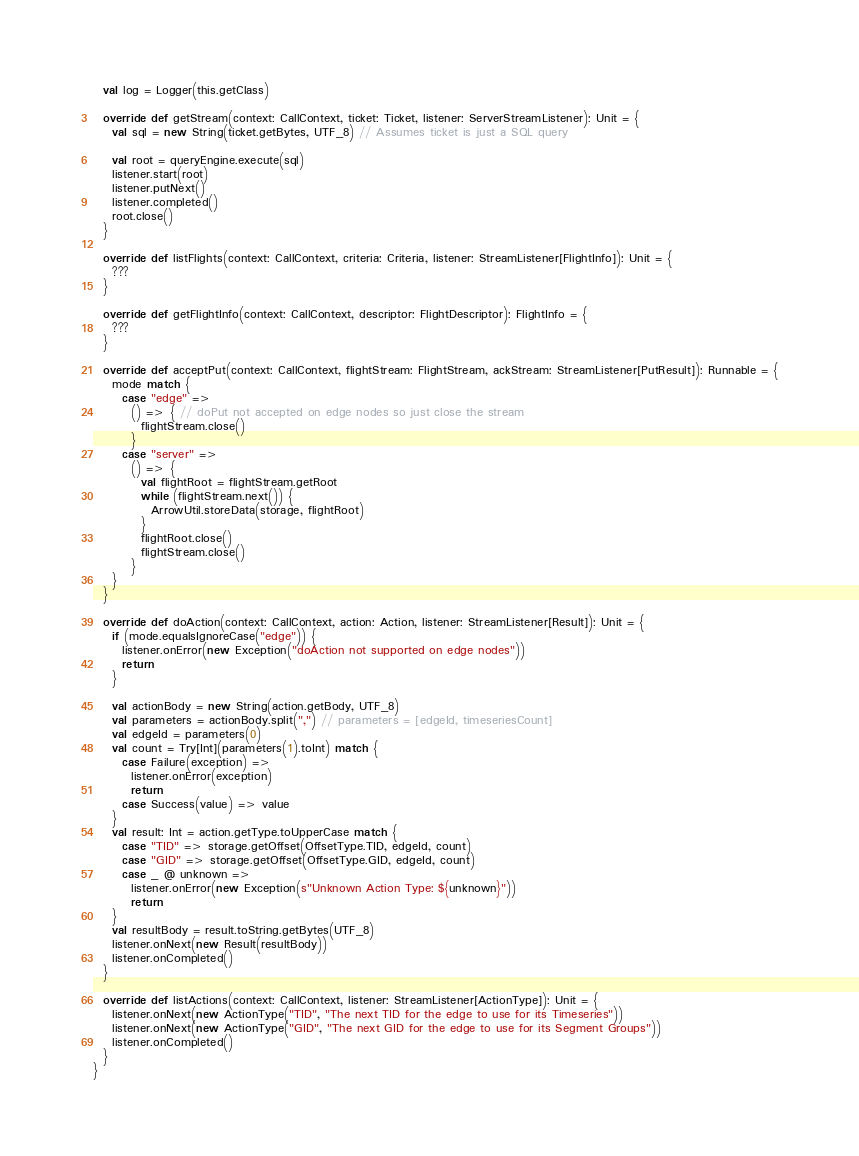Convert code to text. <code><loc_0><loc_0><loc_500><loc_500><_Scala_>
  val log = Logger(this.getClass)

  override def getStream(context: CallContext, ticket: Ticket, listener: ServerStreamListener): Unit = {
    val sql = new String(ticket.getBytes, UTF_8) // Assumes ticket is just a SQL query

    val root = queryEngine.execute(sql)
    listener.start(root)
    listener.putNext()
    listener.completed()
    root.close()
  }

  override def listFlights(context: CallContext, criteria: Criteria, listener: StreamListener[FlightInfo]): Unit = {
    ???
  }

  override def getFlightInfo(context: CallContext, descriptor: FlightDescriptor): FlightInfo = {
    ???
  }

  override def acceptPut(context: CallContext, flightStream: FlightStream, ackStream: StreamListener[PutResult]): Runnable = {
    mode match {
      case "edge" =>
        () => { // doPut not accepted on edge nodes so just close the stream
          flightStream.close()
        }
      case "server" =>
        () => {
          val flightRoot = flightStream.getRoot
          while (flightStream.next()) {
            ArrowUtil.storeData(storage, flightRoot)
          }
          flightRoot.close()
          flightStream.close()
        }
    }
  }

  override def doAction(context: CallContext, action: Action, listener: StreamListener[Result]): Unit = {
    if (mode.equalsIgnoreCase("edge")) {
      listener.onError(new Exception("doAction not supported on edge nodes"))
      return
    }

    val actionBody = new String(action.getBody, UTF_8)
    val parameters = actionBody.split(",") // parameters = [edgeId, timeseriesCount]
    val edgeId = parameters(0)
    val count = Try[Int](parameters(1).toInt) match {
      case Failure(exception) =>
        listener.onError(exception)
        return
      case Success(value) => value
    }
    val result: Int = action.getType.toUpperCase match {
      case "TID" => storage.getOffset(OffsetType.TID, edgeId, count)
      case "GID" => storage.getOffset(OffsetType.GID, edgeId, count)
      case _ @ unknown =>
        listener.onError(new Exception(s"Unknown Action Type: ${unknown}"))
        return
    }
    val resultBody = result.toString.getBytes(UTF_8)
    listener.onNext(new Result(resultBody))
    listener.onCompleted()
  }

  override def listActions(context: CallContext, listener: StreamListener[ActionType]): Unit = {
    listener.onNext(new ActionType("TID", "The next TID for the edge to use for its Timeseries"))
    listener.onNext(new ActionType("GID", "The next GID for the edge to use for its Segment Groups"))
    listener.onCompleted()
  }
}
</code> 